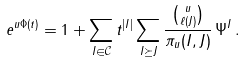<formula> <loc_0><loc_0><loc_500><loc_500>e ^ { u \Phi ( t ) } & = 1 + \sum _ { I \in \mathcal { C } } t ^ { | I | } \sum _ { I \succeq J } \frac { \binom { u } { \ell ( J ) } } { \pi _ { u } ( I , J ) } \, \Psi ^ { I } \, .</formula> 